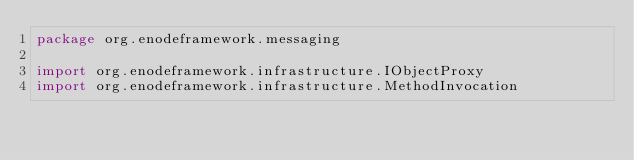<code> <loc_0><loc_0><loc_500><loc_500><_Kotlin_>package org.enodeframework.messaging

import org.enodeframework.infrastructure.IObjectProxy
import org.enodeframework.infrastructure.MethodInvocation
</code> 